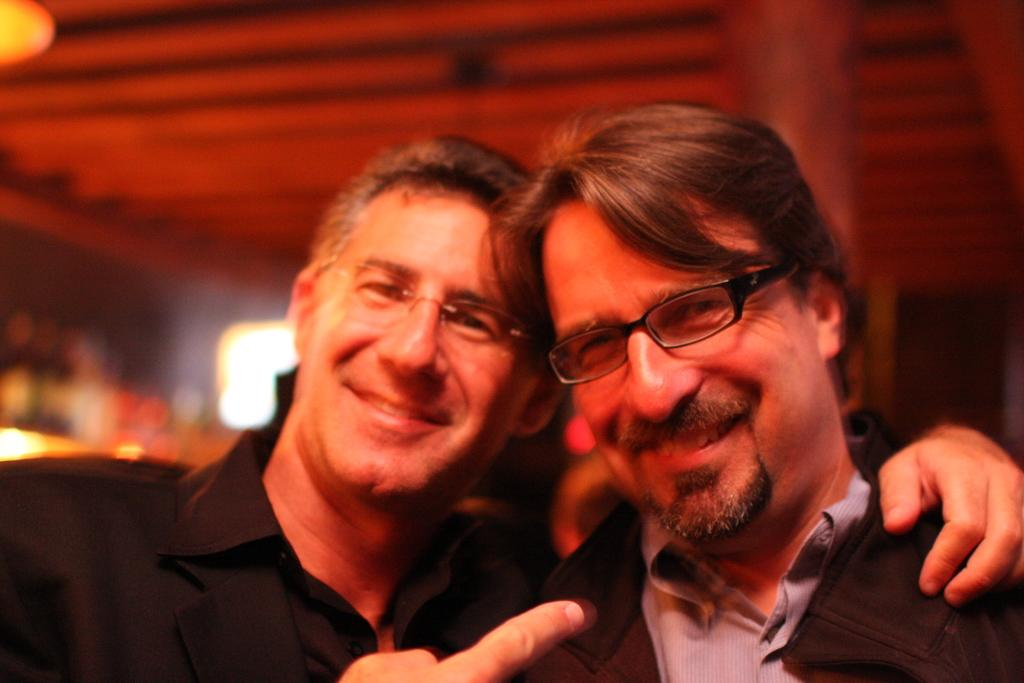How many people are in the image? There are two persons in the image. What are the persons wearing? The persons are wearing clothes. Can you describe the background of the image? The background of the image is blurred. What type of mine can be seen in the background of the image? There is no mine present in the image; the background is blurred. What is the color of the engine in the image? There is no engine present in the image. 